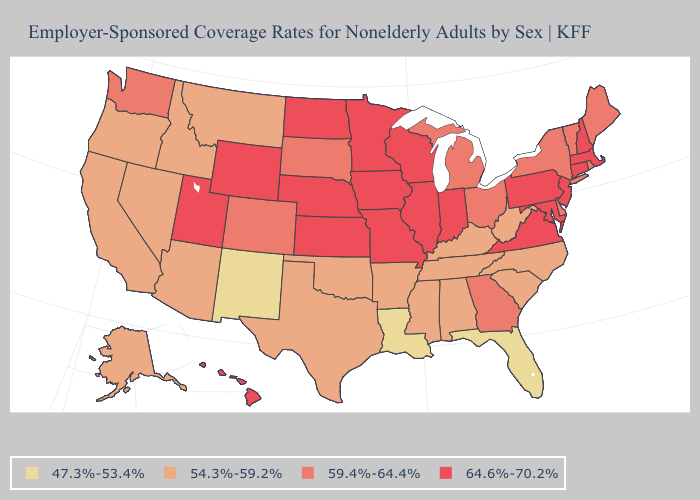Does Pennsylvania have the highest value in the USA?
Quick response, please. Yes. Does Pennsylvania have the highest value in the USA?
Answer briefly. Yes. Which states have the highest value in the USA?
Short answer required. Connecticut, Hawaii, Illinois, Indiana, Iowa, Kansas, Maryland, Massachusetts, Minnesota, Missouri, Nebraska, New Hampshire, New Jersey, North Dakota, Pennsylvania, Utah, Virginia, Wisconsin, Wyoming. Among the states that border New Jersey , which have the highest value?
Write a very short answer. Pennsylvania. What is the highest value in states that border Louisiana?
Be succinct. 54.3%-59.2%. Among the states that border Kansas , which have the highest value?
Give a very brief answer. Missouri, Nebraska. Is the legend a continuous bar?
Keep it brief. No. Which states have the lowest value in the USA?
Short answer required. Florida, Louisiana, New Mexico. Is the legend a continuous bar?
Concise answer only. No. What is the value of Texas?
Quick response, please. 54.3%-59.2%. What is the highest value in the South ?
Quick response, please. 64.6%-70.2%. Name the states that have a value in the range 59.4%-64.4%?
Quick response, please. Colorado, Delaware, Georgia, Maine, Michigan, New York, Ohio, Rhode Island, South Dakota, Vermont, Washington. What is the highest value in the USA?
Short answer required. 64.6%-70.2%. What is the lowest value in states that border Ohio?
Write a very short answer. 54.3%-59.2%. 